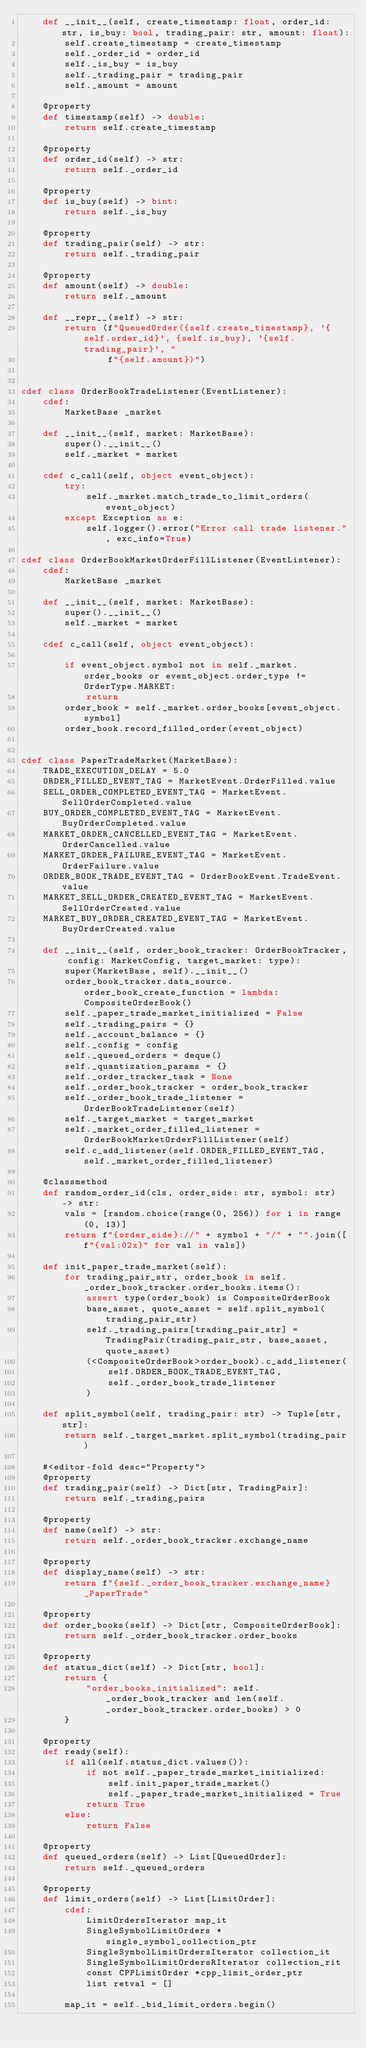Convert code to text. <code><loc_0><loc_0><loc_500><loc_500><_Cython_>    def __init__(self, create_timestamp: float, order_id: str, is_buy: bool, trading_pair: str, amount: float):
        self.create_timestamp = create_timestamp
        self._order_id = order_id
        self._is_buy = is_buy
        self._trading_pair = trading_pair
        self._amount = amount

    @property
    def timestamp(self) -> double:
        return self.create_timestamp

    @property
    def order_id(self) -> str:
        return self._order_id

    @property
    def is_buy(self) -> bint:
        return self._is_buy

    @property
    def trading_pair(self) -> str:
        return self._trading_pair

    @property
    def amount(self) -> double:
        return self._amount

    def __repr__(self) -> str:
        return (f"QueuedOrder({self.create_timestamp}, '{self.order_id}', {self.is_buy}, '{self.trading_pair}', "
                f"{self.amount})")


cdef class OrderBookTradeListener(EventListener):
    cdef:
        MarketBase _market

    def __init__(self, market: MarketBase):
        super().__init__()
        self._market = market

    cdef c_call(self, object event_object):
        try:
            self._market.match_trade_to_limit_orders(event_object)
        except Exception as e:
            self.logger().error("Error call trade listener.", exc_info=True)

cdef class OrderBookMarketOrderFillListener(EventListener):
    cdef:
        MarketBase _market

    def __init__(self, market: MarketBase):
        super().__init__()
        self._market = market

    cdef c_call(self, object event_object):

        if event_object.symbol not in self._market.order_books or event_object.order_type != OrderType.MARKET:
            return
        order_book = self._market.order_books[event_object.symbol]
        order_book.record_filled_order(event_object)


cdef class PaperTradeMarket(MarketBase):
    TRADE_EXECUTION_DELAY = 5.0
    ORDER_FILLED_EVENT_TAG = MarketEvent.OrderFilled.value
    SELL_ORDER_COMPLETED_EVENT_TAG = MarketEvent.SellOrderCompleted.value
    BUY_ORDER_COMPLETED_EVENT_TAG = MarketEvent.BuyOrderCompleted.value
    MARKET_ORDER_CANCELLED_EVENT_TAG = MarketEvent.OrderCancelled.value
    MARKET_ORDER_FAILURE_EVENT_TAG = MarketEvent.OrderFailure.value
    ORDER_BOOK_TRADE_EVENT_TAG = OrderBookEvent.TradeEvent.value
    MARKET_SELL_ORDER_CREATED_EVENT_TAG = MarketEvent.SellOrderCreated.value
    MARKET_BUY_ORDER_CREATED_EVENT_TAG = MarketEvent.BuyOrderCreated.value

    def __init__(self, order_book_tracker: OrderBookTracker, config: MarketConfig, target_market: type):
        super(MarketBase, self).__init__()
        order_book_tracker.data_source.order_book_create_function = lambda: CompositeOrderBook()
        self._paper_trade_market_initialized = False
        self._trading_pairs = {}
        self._account_balance = {}
        self._config = config
        self._queued_orders = deque()
        self._quantization_params = {}
        self._order_tracker_task = None
        self._order_book_tracker = order_book_tracker
        self._order_book_trade_listener = OrderBookTradeListener(self)
        self._target_market = target_market
        self._market_order_filled_listener = OrderBookMarketOrderFillListener(self)
        self.c_add_listener(self.ORDER_FILLED_EVENT_TAG, self._market_order_filled_listener)

    @classmethod
    def random_order_id(cls, order_side: str, symbol: str) -> str:
        vals = [random.choice(range(0, 256)) for i in range(0, 13)]
        return f"{order_side}://" + symbol + "/" + "".join([f"{val:02x}" for val in vals])

    def init_paper_trade_market(self):
        for trading_pair_str, order_book in self._order_book_tracker.order_books.items():
            assert type(order_book) is CompositeOrderBook
            base_asset, quote_asset = self.split_symbol(trading_pair_str)
            self._trading_pairs[trading_pair_str] = TradingPair(trading_pair_str, base_asset, quote_asset)
            (<CompositeOrderBook>order_book).c_add_listener(
                self.ORDER_BOOK_TRADE_EVENT_TAG,
                self._order_book_trade_listener
            )

    def split_symbol(self, trading_pair: str) -> Tuple[str, str]:
        return self._target_market.split_symbol(trading_pair)

    #<editor-fold desc="Property">
    @property
    def trading_pair(self) -> Dict[str, TradingPair]:
        return self._trading_pairs

    @property
    def name(self) -> str:
        return self._order_book_tracker.exchange_name

    @property
    def display_name(self) -> str:
        return f"{self._order_book_tracker.exchange_name}_PaperTrade"

    @property
    def order_books(self) -> Dict[str, CompositeOrderBook]:
        return self._order_book_tracker.order_books

    @property
    def status_dict(self) -> Dict[str, bool]:
        return {
            "order_books_initialized": self._order_book_tracker and len(self._order_book_tracker.order_books) > 0
        }

    @property
    def ready(self):
        if all(self.status_dict.values()):
            if not self._paper_trade_market_initialized:
                self.init_paper_trade_market()
                self._paper_trade_market_initialized = True
            return True
        else:
            return False

    @property
    def queued_orders(self) -> List[QueuedOrder]:
        return self._queued_orders

    @property
    def limit_orders(self) -> List[LimitOrder]:
        cdef:
            LimitOrdersIterator map_it
            SingleSymbolLimitOrders *single_symbol_collection_ptr
            SingleSymbolLimitOrdersIterator collection_it
            SingleSymbolLimitOrdersRIterator collection_rit
            const CPPLimitOrder *cpp_limit_order_ptr
            list retval = []

        map_it = self._bid_limit_orders.begin()</code> 